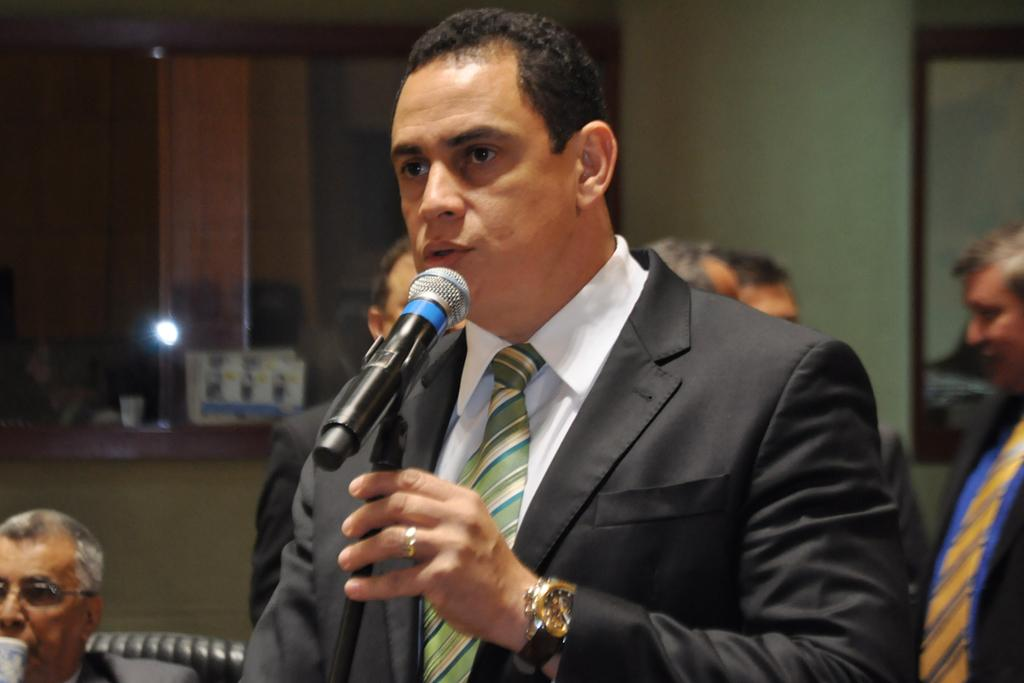What is the man in the image doing? The man is talking in front of a microphone. What is the man wearing in the image? The man is wearing a suit. What object is the man holding in the image? The man is holding a rod. What can be seen in the background of the image? There are people, a wall, and objects in the background of the image. What type of truck can be seen in the image? There is no truck present in the image. Can you describe the goose that is sitting on the man's shoulder in the image? There is no goose present in the image; the man is holding a rod. 